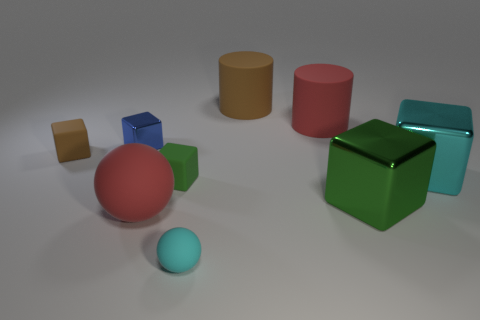Are there any large red things that have the same shape as the cyan rubber thing?
Ensure brevity in your answer.  Yes. There is a red cylinder that is the same material as the small ball; what size is it?
Your response must be concise. Large. What is the color of the large ball?
Give a very brief answer. Red. How many other small rubber balls are the same color as the small sphere?
Give a very brief answer. 0. There is a green cube that is the same size as the brown matte cylinder; what is it made of?
Ensure brevity in your answer.  Metal. Are there any brown matte blocks right of the small rubber cube that is on the right side of the tiny blue thing?
Ensure brevity in your answer.  No. How many other things are there of the same color as the large matte ball?
Your response must be concise. 1. What is the size of the cyan matte sphere?
Ensure brevity in your answer.  Small. Is there a big brown cylinder?
Offer a very short reply. Yes. Is the number of red things that are in front of the small brown rubber thing greater than the number of brown things in front of the big red matte cylinder?
Your response must be concise. No. 